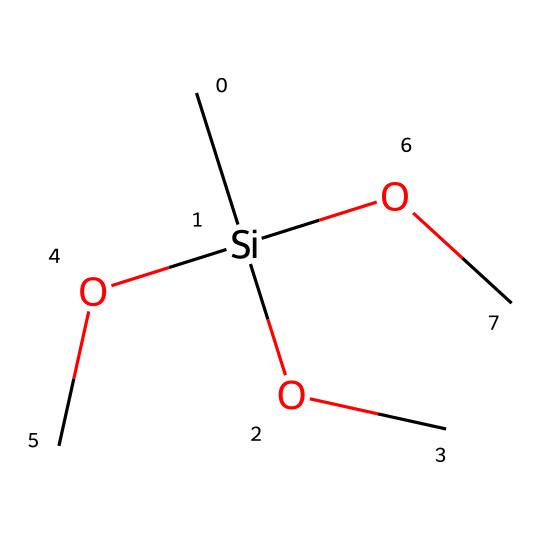What is the central atom in this silane compound? The central atom can be identified by looking at the structure, which consists of silicon (Si) bonded to various groups. Here, silicon is surrounded by three alkoxy groups.
Answer: silicon How many oxygen atoms are present in this silane compound? By analyzing the structure, we can count the number of oxygen (O) atoms connected to the central silicon atom. In this case, there are three oxygen atoms from the three -OC groups.
Answer: three What functional groups are present in this chemical structure? The structure shows that the functional groups connected to silicon are -OC groups, which are ether functional groups. These indicate the presence of alkoxy groups in the silane.
Answer: alkoxy Does this compound have any carbon atoms? Examining the SMILES representation reveals that there are carbon (C) atoms present in the -OC groups attached to the silicon atom. Each -OC group contains one carbon atom, and there are three such groups.
Answer: yes How many total atoms are in the chemical structure? To calculate the total number of atoms, we count each type: 1 silicon, 3 oxygen, and 3 carbon atoms (from the three -OC groups). Thus, the total is 7 atoms when combined.
Answer: seven What kind of bonding is primarily present in this silane? The bonds in this silane compound can be identified as covalent bonds. Silicon forms covalent bonds with each of the oxygen atoms in the alkoxy groups and with the carbon atoms.
Answer: covalent Is this silane compound likely to be hydrophobic or hydrophilic? Based on the presence of multiple alkoxy groups, which can interact with water, this silane compound tends to be more hydrophilic due to its ability to form hydrogen bonds with water molecules.
Answer: hydrophilic 